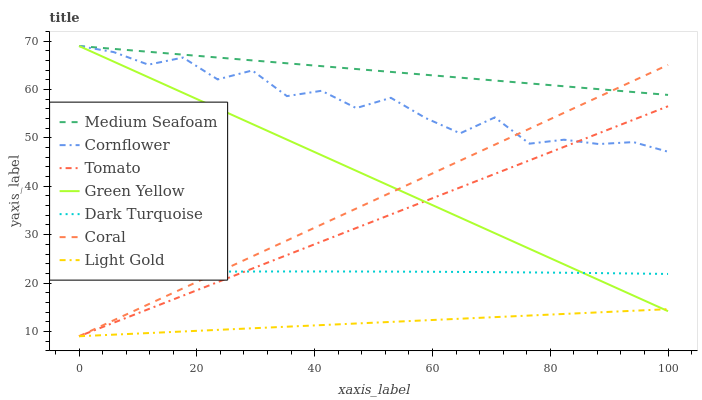Does Cornflower have the minimum area under the curve?
Answer yes or no. No. Does Cornflower have the maximum area under the curve?
Answer yes or no. No. Is Dark Turquoise the smoothest?
Answer yes or no. No. Is Dark Turquoise the roughest?
Answer yes or no. No. Does Cornflower have the lowest value?
Answer yes or no. No. Does Dark Turquoise have the highest value?
Answer yes or no. No. Is Tomato less than Medium Seafoam?
Answer yes or no. Yes. Is Cornflower greater than Dark Turquoise?
Answer yes or no. Yes. Does Tomato intersect Medium Seafoam?
Answer yes or no. No. 